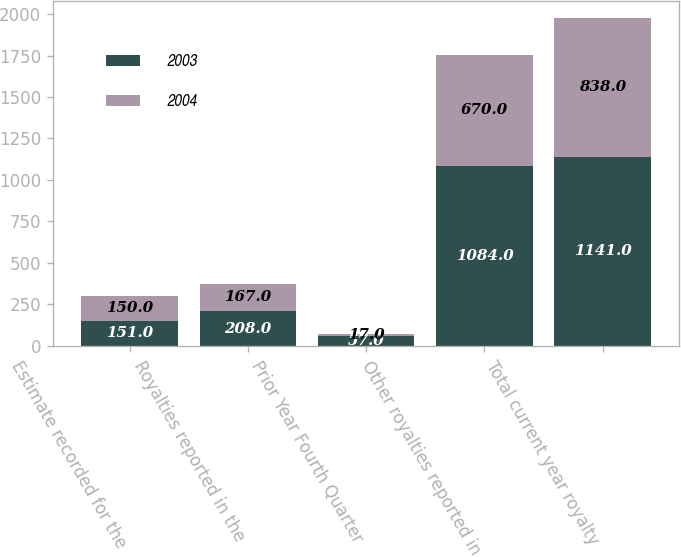Convert chart. <chart><loc_0><loc_0><loc_500><loc_500><stacked_bar_chart><ecel><fcel>Estimate recorded for the<fcel>Royalties reported in the<fcel>Prior Year Fourth Quarter<fcel>Other royalties reported in<fcel>Total current year royalty<nl><fcel>2003<fcel>151<fcel>208<fcel>57<fcel>1084<fcel>1141<nl><fcel>2004<fcel>150<fcel>167<fcel>17<fcel>670<fcel>838<nl></chart> 